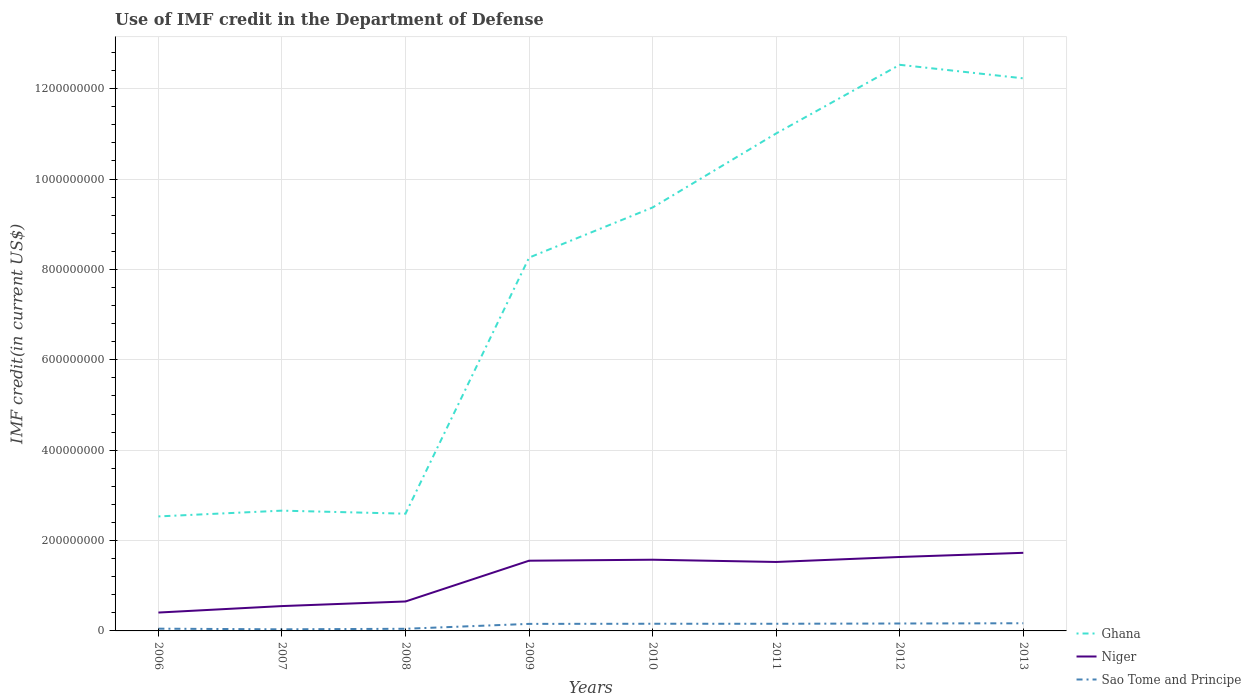Is the number of lines equal to the number of legend labels?
Your response must be concise. Yes. Across all years, what is the maximum IMF credit in the Department of Defense in Ghana?
Offer a very short reply. 2.53e+08. In which year was the IMF credit in the Department of Defense in Ghana maximum?
Offer a very short reply. 2006. What is the total IMF credit in the Department of Defense in Sao Tome and Principe in the graph?
Your answer should be compact. -1.14e+07. What is the difference between the highest and the second highest IMF credit in the Department of Defense in Niger?
Provide a succinct answer. 1.32e+08. What is the difference between the highest and the lowest IMF credit in the Department of Defense in Niger?
Your response must be concise. 5. Is the IMF credit in the Department of Defense in Sao Tome and Principe strictly greater than the IMF credit in the Department of Defense in Niger over the years?
Make the answer very short. Yes. What is the difference between two consecutive major ticks on the Y-axis?
Offer a terse response. 2.00e+08. Does the graph contain any zero values?
Give a very brief answer. No. Does the graph contain grids?
Provide a succinct answer. Yes. What is the title of the graph?
Your response must be concise. Use of IMF credit in the Department of Defense. Does "Czech Republic" appear as one of the legend labels in the graph?
Provide a succinct answer. No. What is the label or title of the X-axis?
Offer a very short reply. Years. What is the label or title of the Y-axis?
Give a very brief answer. IMF credit(in current US$). What is the IMF credit(in current US$) in Ghana in 2006?
Ensure brevity in your answer.  2.53e+08. What is the IMF credit(in current US$) in Niger in 2006?
Your response must be concise. 4.07e+07. What is the IMF credit(in current US$) of Sao Tome and Principe in 2006?
Your answer should be compact. 4.99e+06. What is the IMF credit(in current US$) in Ghana in 2007?
Provide a short and direct response. 2.66e+08. What is the IMF credit(in current US$) in Niger in 2007?
Provide a short and direct response. 5.50e+07. What is the IMF credit(in current US$) in Sao Tome and Principe in 2007?
Your answer should be very brief. 3.55e+06. What is the IMF credit(in current US$) in Ghana in 2008?
Provide a succinct answer. 2.59e+08. What is the IMF credit(in current US$) of Niger in 2008?
Your answer should be very brief. 6.52e+07. What is the IMF credit(in current US$) of Sao Tome and Principe in 2008?
Keep it short and to the point. 4.76e+06. What is the IMF credit(in current US$) in Ghana in 2009?
Ensure brevity in your answer.  8.26e+08. What is the IMF credit(in current US$) of Niger in 2009?
Offer a very short reply. 1.55e+08. What is the IMF credit(in current US$) in Sao Tome and Principe in 2009?
Offer a terse response. 1.56e+07. What is the IMF credit(in current US$) in Ghana in 2010?
Provide a short and direct response. 9.37e+08. What is the IMF credit(in current US$) in Niger in 2010?
Offer a very short reply. 1.58e+08. What is the IMF credit(in current US$) of Sao Tome and Principe in 2010?
Give a very brief answer. 1.59e+07. What is the IMF credit(in current US$) in Ghana in 2011?
Offer a very short reply. 1.10e+09. What is the IMF credit(in current US$) of Niger in 2011?
Offer a very short reply. 1.53e+08. What is the IMF credit(in current US$) in Sao Tome and Principe in 2011?
Ensure brevity in your answer.  1.58e+07. What is the IMF credit(in current US$) of Ghana in 2012?
Give a very brief answer. 1.25e+09. What is the IMF credit(in current US$) in Niger in 2012?
Offer a very short reply. 1.64e+08. What is the IMF credit(in current US$) in Sao Tome and Principe in 2012?
Provide a short and direct response. 1.64e+07. What is the IMF credit(in current US$) in Ghana in 2013?
Your answer should be very brief. 1.22e+09. What is the IMF credit(in current US$) of Niger in 2013?
Ensure brevity in your answer.  1.73e+08. What is the IMF credit(in current US$) of Sao Tome and Principe in 2013?
Keep it short and to the point. 1.70e+07. Across all years, what is the maximum IMF credit(in current US$) of Ghana?
Your answer should be compact. 1.25e+09. Across all years, what is the maximum IMF credit(in current US$) in Niger?
Offer a very short reply. 1.73e+08. Across all years, what is the maximum IMF credit(in current US$) of Sao Tome and Principe?
Ensure brevity in your answer.  1.70e+07. Across all years, what is the minimum IMF credit(in current US$) of Ghana?
Offer a very short reply. 2.53e+08. Across all years, what is the minimum IMF credit(in current US$) in Niger?
Offer a very short reply. 4.07e+07. Across all years, what is the minimum IMF credit(in current US$) of Sao Tome and Principe?
Provide a succinct answer. 3.55e+06. What is the total IMF credit(in current US$) of Ghana in the graph?
Provide a succinct answer. 6.12e+09. What is the total IMF credit(in current US$) of Niger in the graph?
Give a very brief answer. 9.63e+08. What is the total IMF credit(in current US$) in Sao Tome and Principe in the graph?
Your answer should be compact. 9.40e+07. What is the difference between the IMF credit(in current US$) in Ghana in 2006 and that in 2007?
Ensure brevity in your answer.  -1.28e+07. What is the difference between the IMF credit(in current US$) in Niger in 2006 and that in 2007?
Offer a terse response. -1.43e+07. What is the difference between the IMF credit(in current US$) in Sao Tome and Principe in 2006 and that in 2007?
Make the answer very short. 1.44e+06. What is the difference between the IMF credit(in current US$) in Ghana in 2006 and that in 2008?
Your response must be concise. -6.04e+06. What is the difference between the IMF credit(in current US$) in Niger in 2006 and that in 2008?
Make the answer very short. -2.45e+07. What is the difference between the IMF credit(in current US$) of Sao Tome and Principe in 2006 and that in 2008?
Your answer should be compact. 2.31e+05. What is the difference between the IMF credit(in current US$) of Ghana in 2006 and that in 2009?
Offer a very short reply. -5.73e+08. What is the difference between the IMF credit(in current US$) of Niger in 2006 and that in 2009?
Your answer should be compact. -1.15e+08. What is the difference between the IMF credit(in current US$) of Sao Tome and Principe in 2006 and that in 2009?
Your response must be concise. -1.06e+07. What is the difference between the IMF credit(in current US$) in Ghana in 2006 and that in 2010?
Your answer should be very brief. -6.84e+08. What is the difference between the IMF credit(in current US$) of Niger in 2006 and that in 2010?
Ensure brevity in your answer.  -1.17e+08. What is the difference between the IMF credit(in current US$) of Sao Tome and Principe in 2006 and that in 2010?
Provide a succinct answer. -1.09e+07. What is the difference between the IMF credit(in current US$) of Ghana in 2006 and that in 2011?
Make the answer very short. -8.48e+08. What is the difference between the IMF credit(in current US$) in Niger in 2006 and that in 2011?
Your response must be concise. -1.12e+08. What is the difference between the IMF credit(in current US$) of Sao Tome and Principe in 2006 and that in 2011?
Your response must be concise. -1.08e+07. What is the difference between the IMF credit(in current US$) of Ghana in 2006 and that in 2012?
Provide a short and direct response. -9.99e+08. What is the difference between the IMF credit(in current US$) in Niger in 2006 and that in 2012?
Keep it short and to the point. -1.23e+08. What is the difference between the IMF credit(in current US$) of Sao Tome and Principe in 2006 and that in 2012?
Your answer should be compact. -1.14e+07. What is the difference between the IMF credit(in current US$) of Ghana in 2006 and that in 2013?
Provide a succinct answer. -9.69e+08. What is the difference between the IMF credit(in current US$) of Niger in 2006 and that in 2013?
Offer a very short reply. -1.32e+08. What is the difference between the IMF credit(in current US$) of Sao Tome and Principe in 2006 and that in 2013?
Keep it short and to the point. -1.20e+07. What is the difference between the IMF credit(in current US$) in Ghana in 2007 and that in 2008?
Keep it short and to the point. 6.73e+06. What is the difference between the IMF credit(in current US$) in Niger in 2007 and that in 2008?
Your answer should be very brief. -1.02e+07. What is the difference between the IMF credit(in current US$) of Sao Tome and Principe in 2007 and that in 2008?
Make the answer very short. -1.21e+06. What is the difference between the IMF credit(in current US$) in Ghana in 2007 and that in 2009?
Give a very brief answer. -5.60e+08. What is the difference between the IMF credit(in current US$) in Niger in 2007 and that in 2009?
Ensure brevity in your answer.  -1.00e+08. What is the difference between the IMF credit(in current US$) of Sao Tome and Principe in 2007 and that in 2009?
Give a very brief answer. -1.20e+07. What is the difference between the IMF credit(in current US$) in Ghana in 2007 and that in 2010?
Your response must be concise. -6.71e+08. What is the difference between the IMF credit(in current US$) in Niger in 2007 and that in 2010?
Provide a succinct answer. -1.03e+08. What is the difference between the IMF credit(in current US$) in Sao Tome and Principe in 2007 and that in 2010?
Your answer should be very brief. -1.23e+07. What is the difference between the IMF credit(in current US$) in Ghana in 2007 and that in 2011?
Keep it short and to the point. -8.35e+08. What is the difference between the IMF credit(in current US$) of Niger in 2007 and that in 2011?
Your answer should be very brief. -9.76e+07. What is the difference between the IMF credit(in current US$) of Sao Tome and Principe in 2007 and that in 2011?
Make the answer very short. -1.23e+07. What is the difference between the IMF credit(in current US$) of Ghana in 2007 and that in 2012?
Your answer should be compact. -9.87e+08. What is the difference between the IMF credit(in current US$) of Niger in 2007 and that in 2012?
Offer a terse response. -1.09e+08. What is the difference between the IMF credit(in current US$) in Sao Tome and Principe in 2007 and that in 2012?
Provide a succinct answer. -1.29e+07. What is the difference between the IMF credit(in current US$) in Ghana in 2007 and that in 2013?
Provide a short and direct response. -9.57e+08. What is the difference between the IMF credit(in current US$) of Niger in 2007 and that in 2013?
Your response must be concise. -1.18e+08. What is the difference between the IMF credit(in current US$) of Sao Tome and Principe in 2007 and that in 2013?
Offer a very short reply. -1.34e+07. What is the difference between the IMF credit(in current US$) in Ghana in 2008 and that in 2009?
Keep it short and to the point. -5.67e+08. What is the difference between the IMF credit(in current US$) in Niger in 2008 and that in 2009?
Your answer should be very brief. -9.02e+07. What is the difference between the IMF credit(in current US$) in Sao Tome and Principe in 2008 and that in 2009?
Make the answer very short. -1.08e+07. What is the difference between the IMF credit(in current US$) of Ghana in 2008 and that in 2010?
Provide a succinct answer. -6.78e+08. What is the difference between the IMF credit(in current US$) of Niger in 2008 and that in 2010?
Your response must be concise. -9.24e+07. What is the difference between the IMF credit(in current US$) in Sao Tome and Principe in 2008 and that in 2010?
Your response must be concise. -1.11e+07. What is the difference between the IMF credit(in current US$) in Ghana in 2008 and that in 2011?
Provide a succinct answer. -8.41e+08. What is the difference between the IMF credit(in current US$) of Niger in 2008 and that in 2011?
Your answer should be very brief. -8.74e+07. What is the difference between the IMF credit(in current US$) in Sao Tome and Principe in 2008 and that in 2011?
Your answer should be compact. -1.11e+07. What is the difference between the IMF credit(in current US$) of Ghana in 2008 and that in 2012?
Your response must be concise. -9.93e+08. What is the difference between the IMF credit(in current US$) in Niger in 2008 and that in 2012?
Provide a succinct answer. -9.85e+07. What is the difference between the IMF credit(in current US$) of Sao Tome and Principe in 2008 and that in 2012?
Offer a very short reply. -1.17e+07. What is the difference between the IMF credit(in current US$) in Ghana in 2008 and that in 2013?
Provide a succinct answer. -9.63e+08. What is the difference between the IMF credit(in current US$) of Niger in 2008 and that in 2013?
Ensure brevity in your answer.  -1.08e+08. What is the difference between the IMF credit(in current US$) in Sao Tome and Principe in 2008 and that in 2013?
Your answer should be compact. -1.22e+07. What is the difference between the IMF credit(in current US$) of Ghana in 2009 and that in 2010?
Offer a terse response. -1.11e+08. What is the difference between the IMF credit(in current US$) in Niger in 2009 and that in 2010?
Your answer should be very brief. -2.18e+06. What is the difference between the IMF credit(in current US$) of Sao Tome and Principe in 2009 and that in 2010?
Provide a succinct answer. -2.94e+05. What is the difference between the IMF credit(in current US$) in Ghana in 2009 and that in 2011?
Keep it short and to the point. -2.75e+08. What is the difference between the IMF credit(in current US$) of Niger in 2009 and that in 2011?
Give a very brief answer. 2.82e+06. What is the difference between the IMF credit(in current US$) of Sao Tome and Principe in 2009 and that in 2011?
Offer a terse response. -2.45e+05. What is the difference between the IMF credit(in current US$) of Ghana in 2009 and that in 2012?
Provide a short and direct response. -4.27e+08. What is the difference between the IMF credit(in current US$) in Niger in 2009 and that in 2012?
Your response must be concise. -8.22e+06. What is the difference between the IMF credit(in current US$) of Sao Tome and Principe in 2009 and that in 2012?
Your answer should be very brief. -8.31e+05. What is the difference between the IMF credit(in current US$) of Ghana in 2009 and that in 2013?
Your response must be concise. -3.97e+08. What is the difference between the IMF credit(in current US$) of Niger in 2009 and that in 2013?
Provide a short and direct response. -1.74e+07. What is the difference between the IMF credit(in current US$) of Sao Tome and Principe in 2009 and that in 2013?
Keep it short and to the point. -1.39e+06. What is the difference between the IMF credit(in current US$) of Ghana in 2010 and that in 2011?
Your response must be concise. -1.64e+08. What is the difference between the IMF credit(in current US$) of Niger in 2010 and that in 2011?
Offer a terse response. 5.00e+06. What is the difference between the IMF credit(in current US$) in Sao Tome and Principe in 2010 and that in 2011?
Your answer should be very brief. 4.90e+04. What is the difference between the IMF credit(in current US$) of Ghana in 2010 and that in 2012?
Offer a very short reply. -3.16e+08. What is the difference between the IMF credit(in current US$) in Niger in 2010 and that in 2012?
Offer a terse response. -6.04e+06. What is the difference between the IMF credit(in current US$) in Sao Tome and Principe in 2010 and that in 2012?
Provide a succinct answer. -5.37e+05. What is the difference between the IMF credit(in current US$) in Ghana in 2010 and that in 2013?
Provide a short and direct response. -2.86e+08. What is the difference between the IMF credit(in current US$) in Niger in 2010 and that in 2013?
Your answer should be compact. -1.53e+07. What is the difference between the IMF credit(in current US$) in Sao Tome and Principe in 2010 and that in 2013?
Provide a succinct answer. -1.10e+06. What is the difference between the IMF credit(in current US$) in Ghana in 2011 and that in 2012?
Your answer should be compact. -1.52e+08. What is the difference between the IMF credit(in current US$) in Niger in 2011 and that in 2012?
Your answer should be very brief. -1.10e+07. What is the difference between the IMF credit(in current US$) in Sao Tome and Principe in 2011 and that in 2012?
Offer a terse response. -5.86e+05. What is the difference between the IMF credit(in current US$) of Ghana in 2011 and that in 2013?
Ensure brevity in your answer.  -1.22e+08. What is the difference between the IMF credit(in current US$) in Niger in 2011 and that in 2013?
Keep it short and to the point. -2.03e+07. What is the difference between the IMF credit(in current US$) of Sao Tome and Principe in 2011 and that in 2013?
Offer a terse response. -1.15e+06. What is the difference between the IMF credit(in current US$) in Ghana in 2012 and that in 2013?
Provide a succinct answer. 3.00e+07. What is the difference between the IMF credit(in current US$) in Niger in 2012 and that in 2013?
Keep it short and to the point. -9.23e+06. What is the difference between the IMF credit(in current US$) in Sao Tome and Principe in 2012 and that in 2013?
Keep it short and to the point. -5.61e+05. What is the difference between the IMF credit(in current US$) in Ghana in 2006 and the IMF credit(in current US$) in Niger in 2007?
Provide a succinct answer. 1.98e+08. What is the difference between the IMF credit(in current US$) in Ghana in 2006 and the IMF credit(in current US$) in Sao Tome and Principe in 2007?
Your response must be concise. 2.50e+08. What is the difference between the IMF credit(in current US$) of Niger in 2006 and the IMF credit(in current US$) of Sao Tome and Principe in 2007?
Offer a very short reply. 3.71e+07. What is the difference between the IMF credit(in current US$) in Ghana in 2006 and the IMF credit(in current US$) in Niger in 2008?
Provide a short and direct response. 1.88e+08. What is the difference between the IMF credit(in current US$) of Ghana in 2006 and the IMF credit(in current US$) of Sao Tome and Principe in 2008?
Provide a succinct answer. 2.49e+08. What is the difference between the IMF credit(in current US$) in Niger in 2006 and the IMF credit(in current US$) in Sao Tome and Principe in 2008?
Give a very brief answer. 3.59e+07. What is the difference between the IMF credit(in current US$) of Ghana in 2006 and the IMF credit(in current US$) of Niger in 2009?
Give a very brief answer. 9.80e+07. What is the difference between the IMF credit(in current US$) in Ghana in 2006 and the IMF credit(in current US$) in Sao Tome and Principe in 2009?
Give a very brief answer. 2.38e+08. What is the difference between the IMF credit(in current US$) in Niger in 2006 and the IMF credit(in current US$) in Sao Tome and Principe in 2009?
Provide a succinct answer. 2.51e+07. What is the difference between the IMF credit(in current US$) of Ghana in 2006 and the IMF credit(in current US$) of Niger in 2010?
Provide a succinct answer. 9.58e+07. What is the difference between the IMF credit(in current US$) in Ghana in 2006 and the IMF credit(in current US$) in Sao Tome and Principe in 2010?
Your answer should be very brief. 2.38e+08. What is the difference between the IMF credit(in current US$) in Niger in 2006 and the IMF credit(in current US$) in Sao Tome and Principe in 2010?
Your answer should be compact. 2.48e+07. What is the difference between the IMF credit(in current US$) in Ghana in 2006 and the IMF credit(in current US$) in Niger in 2011?
Give a very brief answer. 1.01e+08. What is the difference between the IMF credit(in current US$) in Ghana in 2006 and the IMF credit(in current US$) in Sao Tome and Principe in 2011?
Ensure brevity in your answer.  2.38e+08. What is the difference between the IMF credit(in current US$) of Niger in 2006 and the IMF credit(in current US$) of Sao Tome and Principe in 2011?
Provide a succinct answer. 2.48e+07. What is the difference between the IMF credit(in current US$) of Ghana in 2006 and the IMF credit(in current US$) of Niger in 2012?
Your answer should be compact. 8.98e+07. What is the difference between the IMF credit(in current US$) in Ghana in 2006 and the IMF credit(in current US$) in Sao Tome and Principe in 2012?
Give a very brief answer. 2.37e+08. What is the difference between the IMF credit(in current US$) of Niger in 2006 and the IMF credit(in current US$) of Sao Tome and Principe in 2012?
Give a very brief answer. 2.43e+07. What is the difference between the IMF credit(in current US$) of Ghana in 2006 and the IMF credit(in current US$) of Niger in 2013?
Offer a very short reply. 8.05e+07. What is the difference between the IMF credit(in current US$) in Ghana in 2006 and the IMF credit(in current US$) in Sao Tome and Principe in 2013?
Offer a very short reply. 2.36e+08. What is the difference between the IMF credit(in current US$) in Niger in 2006 and the IMF credit(in current US$) in Sao Tome and Principe in 2013?
Give a very brief answer. 2.37e+07. What is the difference between the IMF credit(in current US$) of Ghana in 2007 and the IMF credit(in current US$) of Niger in 2008?
Ensure brevity in your answer.  2.01e+08. What is the difference between the IMF credit(in current US$) in Ghana in 2007 and the IMF credit(in current US$) in Sao Tome and Principe in 2008?
Give a very brief answer. 2.61e+08. What is the difference between the IMF credit(in current US$) in Niger in 2007 and the IMF credit(in current US$) in Sao Tome and Principe in 2008?
Offer a very short reply. 5.02e+07. What is the difference between the IMF credit(in current US$) in Ghana in 2007 and the IMF credit(in current US$) in Niger in 2009?
Offer a very short reply. 1.11e+08. What is the difference between the IMF credit(in current US$) in Ghana in 2007 and the IMF credit(in current US$) in Sao Tome and Principe in 2009?
Offer a very short reply. 2.51e+08. What is the difference between the IMF credit(in current US$) of Niger in 2007 and the IMF credit(in current US$) of Sao Tome and Principe in 2009?
Your answer should be very brief. 3.94e+07. What is the difference between the IMF credit(in current US$) in Ghana in 2007 and the IMF credit(in current US$) in Niger in 2010?
Offer a terse response. 1.09e+08. What is the difference between the IMF credit(in current US$) of Ghana in 2007 and the IMF credit(in current US$) of Sao Tome and Principe in 2010?
Provide a short and direct response. 2.50e+08. What is the difference between the IMF credit(in current US$) in Niger in 2007 and the IMF credit(in current US$) in Sao Tome and Principe in 2010?
Offer a terse response. 3.91e+07. What is the difference between the IMF credit(in current US$) of Ghana in 2007 and the IMF credit(in current US$) of Niger in 2011?
Give a very brief answer. 1.14e+08. What is the difference between the IMF credit(in current US$) in Ghana in 2007 and the IMF credit(in current US$) in Sao Tome and Principe in 2011?
Provide a succinct answer. 2.50e+08. What is the difference between the IMF credit(in current US$) of Niger in 2007 and the IMF credit(in current US$) of Sao Tome and Principe in 2011?
Provide a short and direct response. 3.92e+07. What is the difference between the IMF credit(in current US$) of Ghana in 2007 and the IMF credit(in current US$) of Niger in 2012?
Your answer should be very brief. 1.03e+08. What is the difference between the IMF credit(in current US$) of Ghana in 2007 and the IMF credit(in current US$) of Sao Tome and Principe in 2012?
Your answer should be compact. 2.50e+08. What is the difference between the IMF credit(in current US$) of Niger in 2007 and the IMF credit(in current US$) of Sao Tome and Principe in 2012?
Keep it short and to the point. 3.86e+07. What is the difference between the IMF credit(in current US$) of Ghana in 2007 and the IMF credit(in current US$) of Niger in 2013?
Ensure brevity in your answer.  9.33e+07. What is the difference between the IMF credit(in current US$) of Ghana in 2007 and the IMF credit(in current US$) of Sao Tome and Principe in 2013?
Your answer should be very brief. 2.49e+08. What is the difference between the IMF credit(in current US$) in Niger in 2007 and the IMF credit(in current US$) in Sao Tome and Principe in 2013?
Your answer should be compact. 3.80e+07. What is the difference between the IMF credit(in current US$) of Ghana in 2008 and the IMF credit(in current US$) of Niger in 2009?
Provide a short and direct response. 1.04e+08. What is the difference between the IMF credit(in current US$) of Ghana in 2008 and the IMF credit(in current US$) of Sao Tome and Principe in 2009?
Your answer should be compact. 2.44e+08. What is the difference between the IMF credit(in current US$) in Niger in 2008 and the IMF credit(in current US$) in Sao Tome and Principe in 2009?
Offer a very short reply. 4.96e+07. What is the difference between the IMF credit(in current US$) of Ghana in 2008 and the IMF credit(in current US$) of Niger in 2010?
Your response must be concise. 1.02e+08. What is the difference between the IMF credit(in current US$) in Ghana in 2008 and the IMF credit(in current US$) in Sao Tome and Principe in 2010?
Give a very brief answer. 2.44e+08. What is the difference between the IMF credit(in current US$) in Niger in 2008 and the IMF credit(in current US$) in Sao Tome and Principe in 2010?
Offer a very short reply. 4.93e+07. What is the difference between the IMF credit(in current US$) in Ghana in 2008 and the IMF credit(in current US$) in Niger in 2011?
Offer a terse response. 1.07e+08. What is the difference between the IMF credit(in current US$) of Ghana in 2008 and the IMF credit(in current US$) of Sao Tome and Principe in 2011?
Make the answer very short. 2.44e+08. What is the difference between the IMF credit(in current US$) in Niger in 2008 and the IMF credit(in current US$) in Sao Tome and Principe in 2011?
Your response must be concise. 4.93e+07. What is the difference between the IMF credit(in current US$) in Ghana in 2008 and the IMF credit(in current US$) in Niger in 2012?
Your response must be concise. 9.58e+07. What is the difference between the IMF credit(in current US$) of Ghana in 2008 and the IMF credit(in current US$) of Sao Tome and Principe in 2012?
Your answer should be very brief. 2.43e+08. What is the difference between the IMF credit(in current US$) in Niger in 2008 and the IMF credit(in current US$) in Sao Tome and Principe in 2012?
Offer a very short reply. 4.88e+07. What is the difference between the IMF credit(in current US$) of Ghana in 2008 and the IMF credit(in current US$) of Niger in 2013?
Ensure brevity in your answer.  8.66e+07. What is the difference between the IMF credit(in current US$) in Ghana in 2008 and the IMF credit(in current US$) in Sao Tome and Principe in 2013?
Offer a very short reply. 2.42e+08. What is the difference between the IMF credit(in current US$) in Niger in 2008 and the IMF credit(in current US$) in Sao Tome and Principe in 2013?
Keep it short and to the point. 4.82e+07. What is the difference between the IMF credit(in current US$) in Ghana in 2009 and the IMF credit(in current US$) in Niger in 2010?
Ensure brevity in your answer.  6.69e+08. What is the difference between the IMF credit(in current US$) in Ghana in 2009 and the IMF credit(in current US$) in Sao Tome and Principe in 2010?
Your answer should be compact. 8.10e+08. What is the difference between the IMF credit(in current US$) in Niger in 2009 and the IMF credit(in current US$) in Sao Tome and Principe in 2010?
Offer a terse response. 1.40e+08. What is the difference between the IMF credit(in current US$) of Ghana in 2009 and the IMF credit(in current US$) of Niger in 2011?
Keep it short and to the point. 6.74e+08. What is the difference between the IMF credit(in current US$) of Ghana in 2009 and the IMF credit(in current US$) of Sao Tome and Principe in 2011?
Make the answer very short. 8.10e+08. What is the difference between the IMF credit(in current US$) in Niger in 2009 and the IMF credit(in current US$) in Sao Tome and Principe in 2011?
Your answer should be very brief. 1.40e+08. What is the difference between the IMF credit(in current US$) of Ghana in 2009 and the IMF credit(in current US$) of Niger in 2012?
Provide a succinct answer. 6.63e+08. What is the difference between the IMF credit(in current US$) of Ghana in 2009 and the IMF credit(in current US$) of Sao Tome and Principe in 2012?
Keep it short and to the point. 8.10e+08. What is the difference between the IMF credit(in current US$) of Niger in 2009 and the IMF credit(in current US$) of Sao Tome and Principe in 2012?
Make the answer very short. 1.39e+08. What is the difference between the IMF credit(in current US$) in Ghana in 2009 and the IMF credit(in current US$) in Niger in 2013?
Your answer should be very brief. 6.53e+08. What is the difference between the IMF credit(in current US$) of Ghana in 2009 and the IMF credit(in current US$) of Sao Tome and Principe in 2013?
Provide a short and direct response. 8.09e+08. What is the difference between the IMF credit(in current US$) of Niger in 2009 and the IMF credit(in current US$) of Sao Tome and Principe in 2013?
Offer a terse response. 1.38e+08. What is the difference between the IMF credit(in current US$) in Ghana in 2010 and the IMF credit(in current US$) in Niger in 2011?
Provide a short and direct response. 7.84e+08. What is the difference between the IMF credit(in current US$) of Ghana in 2010 and the IMF credit(in current US$) of Sao Tome and Principe in 2011?
Make the answer very short. 9.21e+08. What is the difference between the IMF credit(in current US$) of Niger in 2010 and the IMF credit(in current US$) of Sao Tome and Principe in 2011?
Your answer should be very brief. 1.42e+08. What is the difference between the IMF credit(in current US$) of Ghana in 2010 and the IMF credit(in current US$) of Niger in 2012?
Offer a terse response. 7.73e+08. What is the difference between the IMF credit(in current US$) of Ghana in 2010 and the IMF credit(in current US$) of Sao Tome and Principe in 2012?
Keep it short and to the point. 9.21e+08. What is the difference between the IMF credit(in current US$) in Niger in 2010 and the IMF credit(in current US$) in Sao Tome and Principe in 2012?
Offer a terse response. 1.41e+08. What is the difference between the IMF credit(in current US$) of Ghana in 2010 and the IMF credit(in current US$) of Niger in 2013?
Offer a very short reply. 7.64e+08. What is the difference between the IMF credit(in current US$) of Ghana in 2010 and the IMF credit(in current US$) of Sao Tome and Principe in 2013?
Offer a very short reply. 9.20e+08. What is the difference between the IMF credit(in current US$) of Niger in 2010 and the IMF credit(in current US$) of Sao Tome and Principe in 2013?
Your response must be concise. 1.41e+08. What is the difference between the IMF credit(in current US$) of Ghana in 2011 and the IMF credit(in current US$) of Niger in 2012?
Provide a short and direct response. 9.37e+08. What is the difference between the IMF credit(in current US$) in Ghana in 2011 and the IMF credit(in current US$) in Sao Tome and Principe in 2012?
Provide a short and direct response. 1.08e+09. What is the difference between the IMF credit(in current US$) in Niger in 2011 and the IMF credit(in current US$) in Sao Tome and Principe in 2012?
Your response must be concise. 1.36e+08. What is the difference between the IMF credit(in current US$) in Ghana in 2011 and the IMF credit(in current US$) in Niger in 2013?
Keep it short and to the point. 9.28e+08. What is the difference between the IMF credit(in current US$) in Ghana in 2011 and the IMF credit(in current US$) in Sao Tome and Principe in 2013?
Ensure brevity in your answer.  1.08e+09. What is the difference between the IMF credit(in current US$) in Niger in 2011 and the IMF credit(in current US$) in Sao Tome and Principe in 2013?
Make the answer very short. 1.36e+08. What is the difference between the IMF credit(in current US$) of Ghana in 2012 and the IMF credit(in current US$) of Niger in 2013?
Offer a very short reply. 1.08e+09. What is the difference between the IMF credit(in current US$) of Ghana in 2012 and the IMF credit(in current US$) of Sao Tome and Principe in 2013?
Your answer should be compact. 1.24e+09. What is the difference between the IMF credit(in current US$) of Niger in 2012 and the IMF credit(in current US$) of Sao Tome and Principe in 2013?
Your answer should be very brief. 1.47e+08. What is the average IMF credit(in current US$) of Ghana per year?
Make the answer very short. 7.65e+08. What is the average IMF credit(in current US$) of Niger per year?
Your answer should be very brief. 1.20e+08. What is the average IMF credit(in current US$) in Sao Tome and Principe per year?
Make the answer very short. 1.17e+07. In the year 2006, what is the difference between the IMF credit(in current US$) in Ghana and IMF credit(in current US$) in Niger?
Offer a very short reply. 2.13e+08. In the year 2006, what is the difference between the IMF credit(in current US$) in Ghana and IMF credit(in current US$) in Sao Tome and Principe?
Offer a very short reply. 2.48e+08. In the year 2006, what is the difference between the IMF credit(in current US$) of Niger and IMF credit(in current US$) of Sao Tome and Principe?
Keep it short and to the point. 3.57e+07. In the year 2007, what is the difference between the IMF credit(in current US$) of Ghana and IMF credit(in current US$) of Niger?
Give a very brief answer. 2.11e+08. In the year 2007, what is the difference between the IMF credit(in current US$) of Ghana and IMF credit(in current US$) of Sao Tome and Principe?
Give a very brief answer. 2.63e+08. In the year 2007, what is the difference between the IMF credit(in current US$) of Niger and IMF credit(in current US$) of Sao Tome and Principe?
Your response must be concise. 5.14e+07. In the year 2008, what is the difference between the IMF credit(in current US$) in Ghana and IMF credit(in current US$) in Niger?
Ensure brevity in your answer.  1.94e+08. In the year 2008, what is the difference between the IMF credit(in current US$) of Ghana and IMF credit(in current US$) of Sao Tome and Principe?
Ensure brevity in your answer.  2.55e+08. In the year 2008, what is the difference between the IMF credit(in current US$) in Niger and IMF credit(in current US$) in Sao Tome and Principe?
Make the answer very short. 6.04e+07. In the year 2009, what is the difference between the IMF credit(in current US$) in Ghana and IMF credit(in current US$) in Niger?
Offer a terse response. 6.71e+08. In the year 2009, what is the difference between the IMF credit(in current US$) in Ghana and IMF credit(in current US$) in Sao Tome and Principe?
Give a very brief answer. 8.11e+08. In the year 2009, what is the difference between the IMF credit(in current US$) of Niger and IMF credit(in current US$) of Sao Tome and Principe?
Provide a succinct answer. 1.40e+08. In the year 2010, what is the difference between the IMF credit(in current US$) of Ghana and IMF credit(in current US$) of Niger?
Make the answer very short. 7.79e+08. In the year 2010, what is the difference between the IMF credit(in current US$) in Ghana and IMF credit(in current US$) in Sao Tome and Principe?
Provide a succinct answer. 9.21e+08. In the year 2010, what is the difference between the IMF credit(in current US$) of Niger and IMF credit(in current US$) of Sao Tome and Principe?
Offer a terse response. 1.42e+08. In the year 2011, what is the difference between the IMF credit(in current US$) of Ghana and IMF credit(in current US$) of Niger?
Give a very brief answer. 9.48e+08. In the year 2011, what is the difference between the IMF credit(in current US$) of Ghana and IMF credit(in current US$) of Sao Tome and Principe?
Your answer should be compact. 1.09e+09. In the year 2011, what is the difference between the IMF credit(in current US$) in Niger and IMF credit(in current US$) in Sao Tome and Principe?
Make the answer very short. 1.37e+08. In the year 2012, what is the difference between the IMF credit(in current US$) of Ghana and IMF credit(in current US$) of Niger?
Offer a very short reply. 1.09e+09. In the year 2012, what is the difference between the IMF credit(in current US$) of Ghana and IMF credit(in current US$) of Sao Tome and Principe?
Keep it short and to the point. 1.24e+09. In the year 2012, what is the difference between the IMF credit(in current US$) in Niger and IMF credit(in current US$) in Sao Tome and Principe?
Provide a succinct answer. 1.47e+08. In the year 2013, what is the difference between the IMF credit(in current US$) in Ghana and IMF credit(in current US$) in Niger?
Ensure brevity in your answer.  1.05e+09. In the year 2013, what is the difference between the IMF credit(in current US$) in Ghana and IMF credit(in current US$) in Sao Tome and Principe?
Ensure brevity in your answer.  1.21e+09. In the year 2013, what is the difference between the IMF credit(in current US$) in Niger and IMF credit(in current US$) in Sao Tome and Principe?
Keep it short and to the point. 1.56e+08. What is the ratio of the IMF credit(in current US$) in Niger in 2006 to that in 2007?
Keep it short and to the point. 0.74. What is the ratio of the IMF credit(in current US$) of Sao Tome and Principe in 2006 to that in 2007?
Your response must be concise. 1.41. What is the ratio of the IMF credit(in current US$) of Ghana in 2006 to that in 2008?
Offer a terse response. 0.98. What is the ratio of the IMF credit(in current US$) in Niger in 2006 to that in 2008?
Your answer should be very brief. 0.62. What is the ratio of the IMF credit(in current US$) in Sao Tome and Principe in 2006 to that in 2008?
Offer a terse response. 1.05. What is the ratio of the IMF credit(in current US$) of Ghana in 2006 to that in 2009?
Your answer should be compact. 0.31. What is the ratio of the IMF credit(in current US$) in Niger in 2006 to that in 2009?
Offer a very short reply. 0.26. What is the ratio of the IMF credit(in current US$) of Sao Tome and Principe in 2006 to that in 2009?
Your answer should be compact. 0.32. What is the ratio of the IMF credit(in current US$) in Ghana in 2006 to that in 2010?
Offer a terse response. 0.27. What is the ratio of the IMF credit(in current US$) of Niger in 2006 to that in 2010?
Make the answer very short. 0.26. What is the ratio of the IMF credit(in current US$) in Sao Tome and Principe in 2006 to that in 2010?
Give a very brief answer. 0.31. What is the ratio of the IMF credit(in current US$) of Ghana in 2006 to that in 2011?
Give a very brief answer. 0.23. What is the ratio of the IMF credit(in current US$) in Niger in 2006 to that in 2011?
Your response must be concise. 0.27. What is the ratio of the IMF credit(in current US$) of Sao Tome and Principe in 2006 to that in 2011?
Provide a short and direct response. 0.32. What is the ratio of the IMF credit(in current US$) of Ghana in 2006 to that in 2012?
Provide a succinct answer. 0.2. What is the ratio of the IMF credit(in current US$) in Niger in 2006 to that in 2012?
Your response must be concise. 0.25. What is the ratio of the IMF credit(in current US$) in Sao Tome and Principe in 2006 to that in 2012?
Make the answer very short. 0.3. What is the ratio of the IMF credit(in current US$) of Ghana in 2006 to that in 2013?
Keep it short and to the point. 0.21. What is the ratio of the IMF credit(in current US$) of Niger in 2006 to that in 2013?
Provide a short and direct response. 0.24. What is the ratio of the IMF credit(in current US$) in Sao Tome and Principe in 2006 to that in 2013?
Offer a very short reply. 0.29. What is the ratio of the IMF credit(in current US$) of Ghana in 2007 to that in 2008?
Make the answer very short. 1.03. What is the ratio of the IMF credit(in current US$) in Niger in 2007 to that in 2008?
Offer a terse response. 0.84. What is the ratio of the IMF credit(in current US$) of Sao Tome and Principe in 2007 to that in 2008?
Give a very brief answer. 0.75. What is the ratio of the IMF credit(in current US$) in Ghana in 2007 to that in 2009?
Your answer should be compact. 0.32. What is the ratio of the IMF credit(in current US$) in Niger in 2007 to that in 2009?
Provide a succinct answer. 0.35. What is the ratio of the IMF credit(in current US$) of Sao Tome and Principe in 2007 to that in 2009?
Your answer should be compact. 0.23. What is the ratio of the IMF credit(in current US$) in Ghana in 2007 to that in 2010?
Offer a terse response. 0.28. What is the ratio of the IMF credit(in current US$) of Niger in 2007 to that in 2010?
Provide a short and direct response. 0.35. What is the ratio of the IMF credit(in current US$) in Sao Tome and Principe in 2007 to that in 2010?
Offer a terse response. 0.22. What is the ratio of the IMF credit(in current US$) in Ghana in 2007 to that in 2011?
Give a very brief answer. 0.24. What is the ratio of the IMF credit(in current US$) of Niger in 2007 to that in 2011?
Provide a short and direct response. 0.36. What is the ratio of the IMF credit(in current US$) of Sao Tome and Principe in 2007 to that in 2011?
Provide a succinct answer. 0.22. What is the ratio of the IMF credit(in current US$) of Ghana in 2007 to that in 2012?
Your answer should be very brief. 0.21. What is the ratio of the IMF credit(in current US$) of Niger in 2007 to that in 2012?
Your answer should be compact. 0.34. What is the ratio of the IMF credit(in current US$) in Sao Tome and Principe in 2007 to that in 2012?
Provide a succinct answer. 0.22. What is the ratio of the IMF credit(in current US$) in Ghana in 2007 to that in 2013?
Your response must be concise. 0.22. What is the ratio of the IMF credit(in current US$) in Niger in 2007 to that in 2013?
Provide a short and direct response. 0.32. What is the ratio of the IMF credit(in current US$) of Sao Tome and Principe in 2007 to that in 2013?
Your answer should be very brief. 0.21. What is the ratio of the IMF credit(in current US$) in Ghana in 2008 to that in 2009?
Give a very brief answer. 0.31. What is the ratio of the IMF credit(in current US$) in Niger in 2008 to that in 2009?
Provide a succinct answer. 0.42. What is the ratio of the IMF credit(in current US$) of Sao Tome and Principe in 2008 to that in 2009?
Give a very brief answer. 0.31. What is the ratio of the IMF credit(in current US$) of Ghana in 2008 to that in 2010?
Provide a succinct answer. 0.28. What is the ratio of the IMF credit(in current US$) in Niger in 2008 to that in 2010?
Give a very brief answer. 0.41. What is the ratio of the IMF credit(in current US$) in Sao Tome and Principe in 2008 to that in 2010?
Your answer should be compact. 0.3. What is the ratio of the IMF credit(in current US$) in Ghana in 2008 to that in 2011?
Provide a succinct answer. 0.24. What is the ratio of the IMF credit(in current US$) in Niger in 2008 to that in 2011?
Ensure brevity in your answer.  0.43. What is the ratio of the IMF credit(in current US$) in Sao Tome and Principe in 2008 to that in 2011?
Offer a terse response. 0.3. What is the ratio of the IMF credit(in current US$) of Ghana in 2008 to that in 2012?
Offer a very short reply. 0.21. What is the ratio of the IMF credit(in current US$) of Niger in 2008 to that in 2012?
Provide a short and direct response. 0.4. What is the ratio of the IMF credit(in current US$) in Sao Tome and Principe in 2008 to that in 2012?
Give a very brief answer. 0.29. What is the ratio of the IMF credit(in current US$) in Ghana in 2008 to that in 2013?
Your answer should be compact. 0.21. What is the ratio of the IMF credit(in current US$) in Niger in 2008 to that in 2013?
Give a very brief answer. 0.38. What is the ratio of the IMF credit(in current US$) in Sao Tome and Principe in 2008 to that in 2013?
Ensure brevity in your answer.  0.28. What is the ratio of the IMF credit(in current US$) of Ghana in 2009 to that in 2010?
Keep it short and to the point. 0.88. What is the ratio of the IMF credit(in current US$) of Niger in 2009 to that in 2010?
Give a very brief answer. 0.99. What is the ratio of the IMF credit(in current US$) of Sao Tome and Principe in 2009 to that in 2010?
Provide a short and direct response. 0.98. What is the ratio of the IMF credit(in current US$) in Ghana in 2009 to that in 2011?
Ensure brevity in your answer.  0.75. What is the ratio of the IMF credit(in current US$) of Niger in 2009 to that in 2011?
Provide a short and direct response. 1.02. What is the ratio of the IMF credit(in current US$) in Sao Tome and Principe in 2009 to that in 2011?
Your answer should be compact. 0.98. What is the ratio of the IMF credit(in current US$) of Ghana in 2009 to that in 2012?
Provide a short and direct response. 0.66. What is the ratio of the IMF credit(in current US$) of Niger in 2009 to that in 2012?
Offer a very short reply. 0.95. What is the ratio of the IMF credit(in current US$) in Sao Tome and Principe in 2009 to that in 2012?
Make the answer very short. 0.95. What is the ratio of the IMF credit(in current US$) of Ghana in 2009 to that in 2013?
Your answer should be very brief. 0.68. What is the ratio of the IMF credit(in current US$) of Niger in 2009 to that in 2013?
Give a very brief answer. 0.9. What is the ratio of the IMF credit(in current US$) of Sao Tome and Principe in 2009 to that in 2013?
Your answer should be very brief. 0.92. What is the ratio of the IMF credit(in current US$) of Ghana in 2010 to that in 2011?
Provide a short and direct response. 0.85. What is the ratio of the IMF credit(in current US$) of Niger in 2010 to that in 2011?
Your answer should be very brief. 1.03. What is the ratio of the IMF credit(in current US$) of Sao Tome and Principe in 2010 to that in 2011?
Offer a very short reply. 1. What is the ratio of the IMF credit(in current US$) of Ghana in 2010 to that in 2012?
Your answer should be very brief. 0.75. What is the ratio of the IMF credit(in current US$) in Niger in 2010 to that in 2012?
Offer a very short reply. 0.96. What is the ratio of the IMF credit(in current US$) of Sao Tome and Principe in 2010 to that in 2012?
Your response must be concise. 0.97. What is the ratio of the IMF credit(in current US$) of Ghana in 2010 to that in 2013?
Keep it short and to the point. 0.77. What is the ratio of the IMF credit(in current US$) of Niger in 2010 to that in 2013?
Your answer should be very brief. 0.91. What is the ratio of the IMF credit(in current US$) of Sao Tome and Principe in 2010 to that in 2013?
Offer a terse response. 0.94. What is the ratio of the IMF credit(in current US$) of Ghana in 2011 to that in 2012?
Offer a terse response. 0.88. What is the ratio of the IMF credit(in current US$) in Niger in 2011 to that in 2012?
Keep it short and to the point. 0.93. What is the ratio of the IMF credit(in current US$) in Sao Tome and Principe in 2011 to that in 2012?
Give a very brief answer. 0.96. What is the ratio of the IMF credit(in current US$) of Ghana in 2011 to that in 2013?
Offer a very short reply. 0.9. What is the ratio of the IMF credit(in current US$) of Niger in 2011 to that in 2013?
Ensure brevity in your answer.  0.88. What is the ratio of the IMF credit(in current US$) of Sao Tome and Principe in 2011 to that in 2013?
Provide a short and direct response. 0.93. What is the ratio of the IMF credit(in current US$) of Ghana in 2012 to that in 2013?
Your answer should be compact. 1.02. What is the ratio of the IMF credit(in current US$) in Niger in 2012 to that in 2013?
Your response must be concise. 0.95. What is the ratio of the IMF credit(in current US$) in Sao Tome and Principe in 2012 to that in 2013?
Make the answer very short. 0.97. What is the difference between the highest and the second highest IMF credit(in current US$) in Ghana?
Give a very brief answer. 3.00e+07. What is the difference between the highest and the second highest IMF credit(in current US$) in Niger?
Offer a very short reply. 9.23e+06. What is the difference between the highest and the second highest IMF credit(in current US$) of Sao Tome and Principe?
Provide a succinct answer. 5.61e+05. What is the difference between the highest and the lowest IMF credit(in current US$) in Ghana?
Offer a terse response. 9.99e+08. What is the difference between the highest and the lowest IMF credit(in current US$) of Niger?
Ensure brevity in your answer.  1.32e+08. What is the difference between the highest and the lowest IMF credit(in current US$) of Sao Tome and Principe?
Your answer should be very brief. 1.34e+07. 